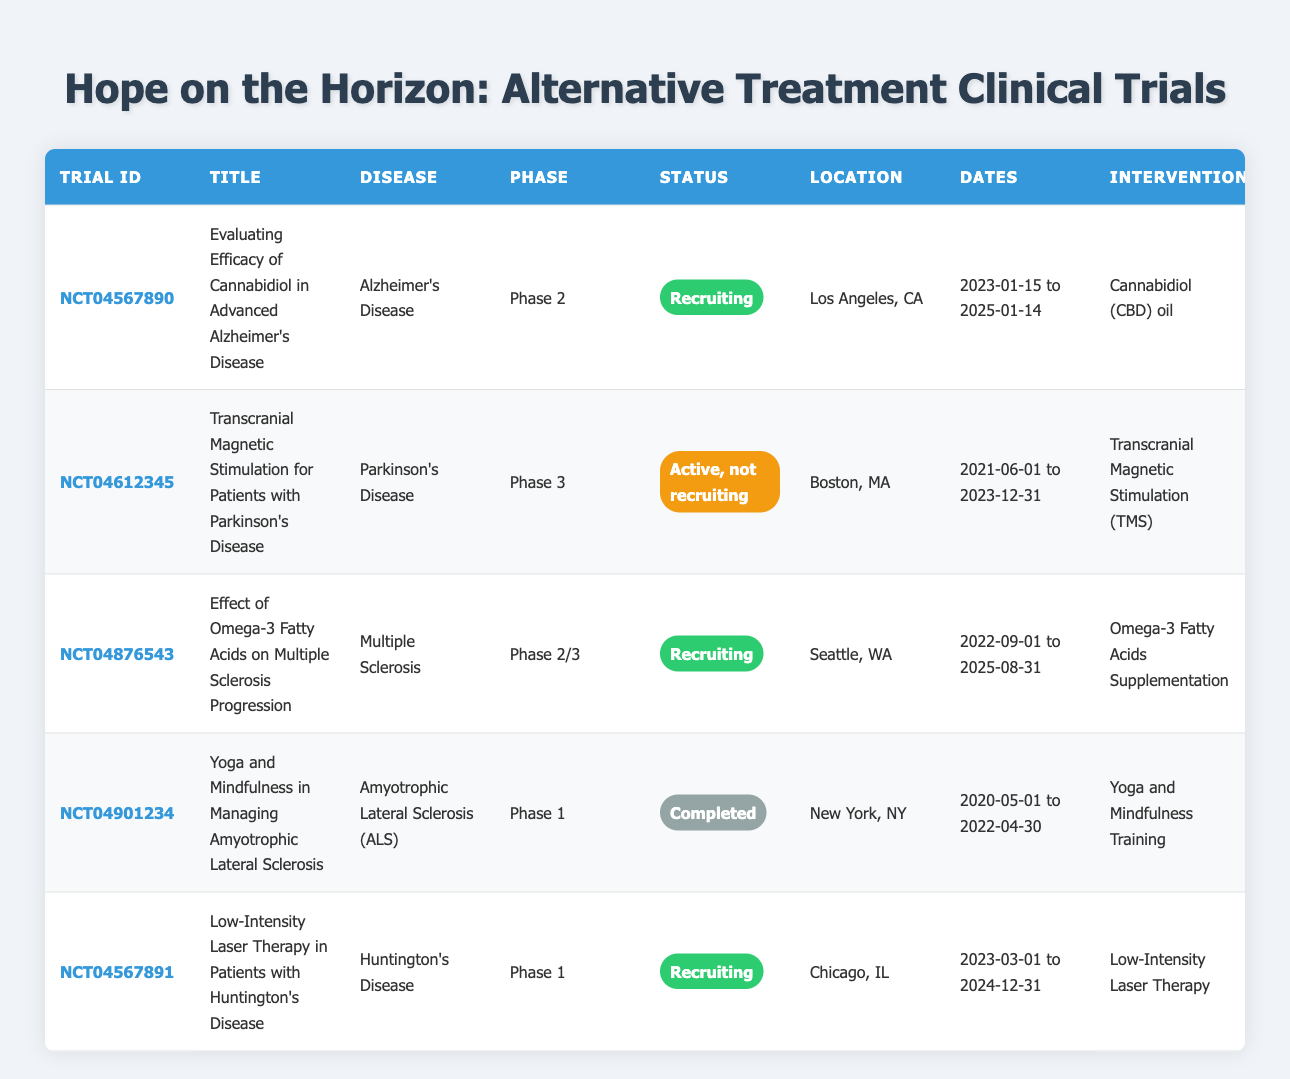What is the title of the trial for Cannabidiol in Alzheimer's Disease? The table shows one row for the trial related to Cannabidiol. The title given in that row is "Evaluating Efficacy of Cannabidiol in Advanced Alzheimer’s Disease."
Answer: Evaluating Efficacy of Cannabidiol in Advanced Alzheimer’s Disease How many clinical trials are currently recruiting participants? By examining the status column of the table, I see that there are three trials listed as "Recruiting": the ones for Cannabidiol, Omega-3 Fatty Acids, and Low-Intensity Laser Therapy. This adds up to three trials.
Answer: 3 What is the intervention used in the trial for Multiple Sclerosis? The row corresponding to the trial for Multiple Sclerosis, titled "Effect of Omega-3 Fatty Acids on Multiple Sclerosis Progression," specifies that the intervention is "Omega-3 Fatty Acids Supplementation."
Answer: Omega-3 Fatty Acids Supplementation Which trial has the longest duration? To find the longest duration, I can look at the end dates provided in the "Dates" column. The trial for Omega-3 Fatty Acids goes until 2025-08-31, which is the furthest in the future compared to the others, thus it has the longest duration from 2022 to 2025.
Answer: Effect of Omega-3 Fatty Acids on Multiple Sclerosis Progression Is there a trial for Yoga and Mindfulness that is currently recruiting? The trial for Yoga and Mindfulness has a status of "Completed," meaning it is no longer recruiting participants. Therefore, the answer is no.
Answer: No In how many cities are these trials taking place? I can see that the trials are located in three different cities: Los Angeles, Boston, Seattle, New York, and Chicago. That counts as five unique cities where the trials are taking place.
Answer: 5 Which two diseases are involved in trials with "Phase 1"? Referring to the phase column in the table, the diseases listed in Phase 1 trials are "Amyotrophic Lateral Sclerosis (ALS)" and "Huntington's Disease." Therefore, the answer involves both diseases.
Answer: Amyotrophic Lateral Sclerosis and Huntington's Disease What is the status of the trial for Transcranial Magnetic Stimulation? The trial for Transcranial Magnetic Stimulation has the status listed as "Active, not recruiting," which indicates that while the trial is still ongoing, it is not currently accepting new participants.
Answer: Active, not recruiting What intervention is used in the trial for Huntington's Disease? By examining the row for Huntington's Disease, I can see that the intervention specified is "Low-Intensity Laser Therapy."
Answer: Low-Intensity Laser Therapy 